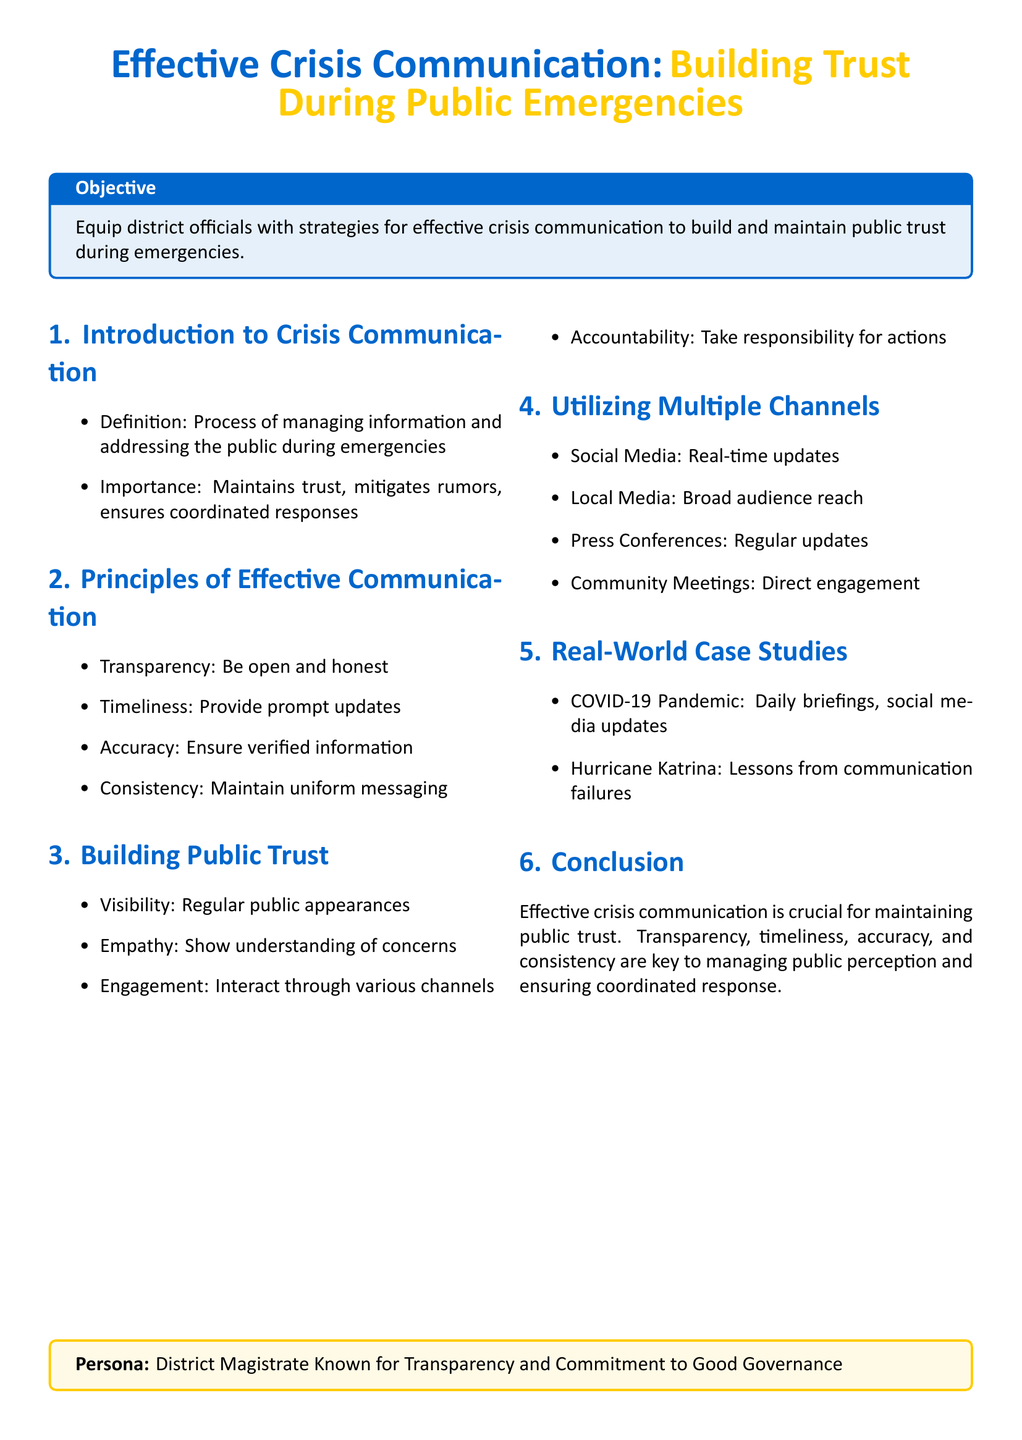What is the main objective of the lesson plan? The objective is to equip district officials with strategies for effective crisis communication to build and maintain public trust during emergencies.
Answer: Equip district officials with strategies for effective crisis communication What is one principle of effective communication mentioned? The document lists several principles, one of which is transparency.
Answer: Transparency Which channel is suggested for real-time updates? The lesson plan specifies social media for real-time updates during crises.
Answer: Social Media What type of engagement is highlighted for building trust? Engagement through various channels is emphasized as a way to build public trust.
Answer: Engagement What significant case study is mentioned related to communication? The COVID-19 Pandemic is referenced as a case study in effective crisis communication.
Answer: COVID-19 Pandemic How many principles of effective communication are listed? The document presents four principles of effective communication.
Answer: Four What is emphasized as crucial for maintaining public trust? The conclusion of the lesson plan states that effective crisis communication is crucial for maintaining public trust.
Answer: Effective crisis communication Which media is identified for broad audience reach? Local media is specifically mentioned for reaching a broad audience in the context of crisis communication.
Answer: Local Media 